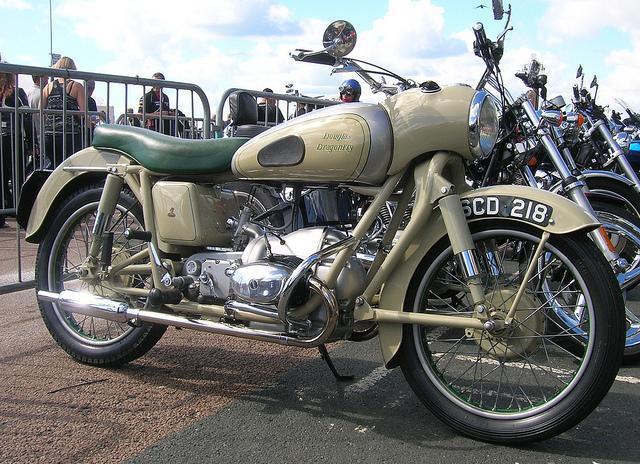How many motorcycles are in the picture?
Give a very brief answer. 3. 